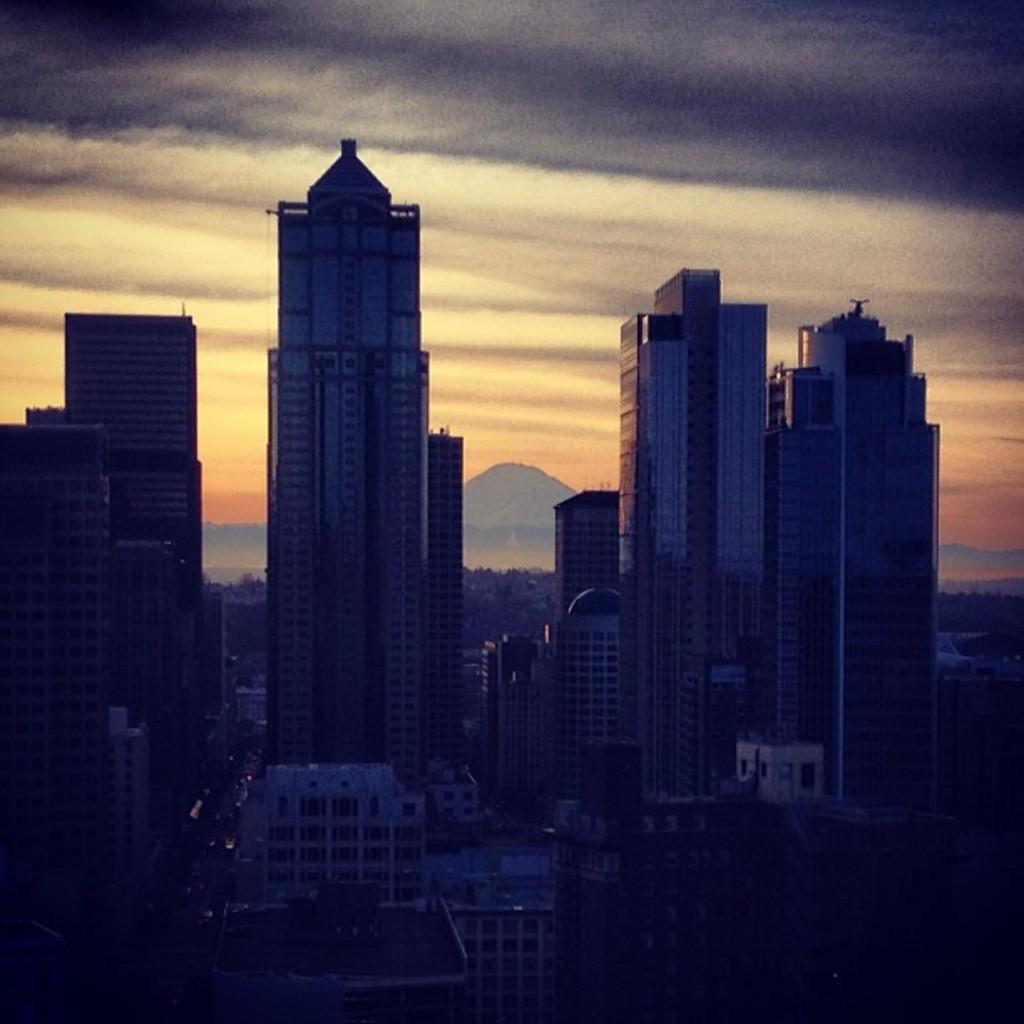Please provide a concise description of this image. In this image there are buildings. In the background there is sky and mountains. 